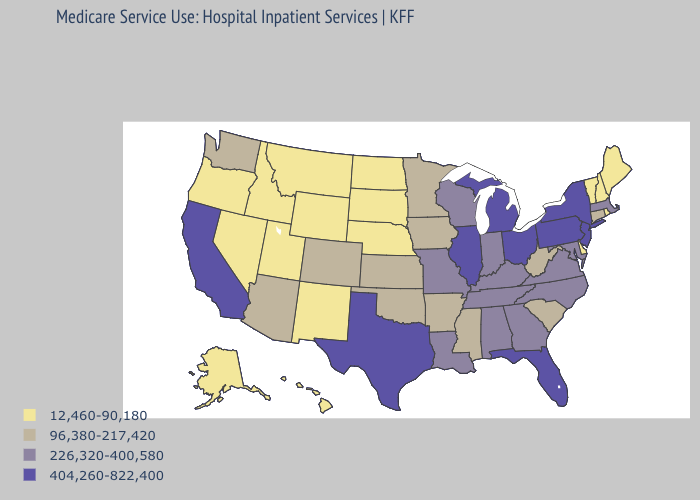What is the value of Wisconsin?
Give a very brief answer. 226,320-400,580. Does Montana have a higher value than Illinois?
Short answer required. No. What is the value of Iowa?
Write a very short answer. 96,380-217,420. Name the states that have a value in the range 404,260-822,400?
Short answer required. California, Florida, Illinois, Michigan, New Jersey, New York, Ohio, Pennsylvania, Texas. Name the states that have a value in the range 96,380-217,420?
Quick response, please. Arizona, Arkansas, Colorado, Connecticut, Iowa, Kansas, Minnesota, Mississippi, Oklahoma, South Carolina, Washington, West Virginia. Does Virginia have the highest value in the USA?
Answer briefly. No. Name the states that have a value in the range 12,460-90,180?
Be succinct. Alaska, Delaware, Hawaii, Idaho, Maine, Montana, Nebraska, Nevada, New Hampshire, New Mexico, North Dakota, Oregon, Rhode Island, South Dakota, Utah, Vermont, Wyoming. What is the value of New Mexico?
Be succinct. 12,460-90,180. Does Nebraska have the lowest value in the MidWest?
Be succinct. Yes. Name the states that have a value in the range 12,460-90,180?
Concise answer only. Alaska, Delaware, Hawaii, Idaho, Maine, Montana, Nebraska, Nevada, New Hampshire, New Mexico, North Dakota, Oregon, Rhode Island, South Dakota, Utah, Vermont, Wyoming. What is the value of Nevada?
Give a very brief answer. 12,460-90,180. What is the value of New Hampshire?
Write a very short answer. 12,460-90,180. Does Colorado have a higher value than Nebraska?
Give a very brief answer. Yes. What is the highest value in states that border Oregon?
Give a very brief answer. 404,260-822,400. What is the value of Arkansas?
Quick response, please. 96,380-217,420. 